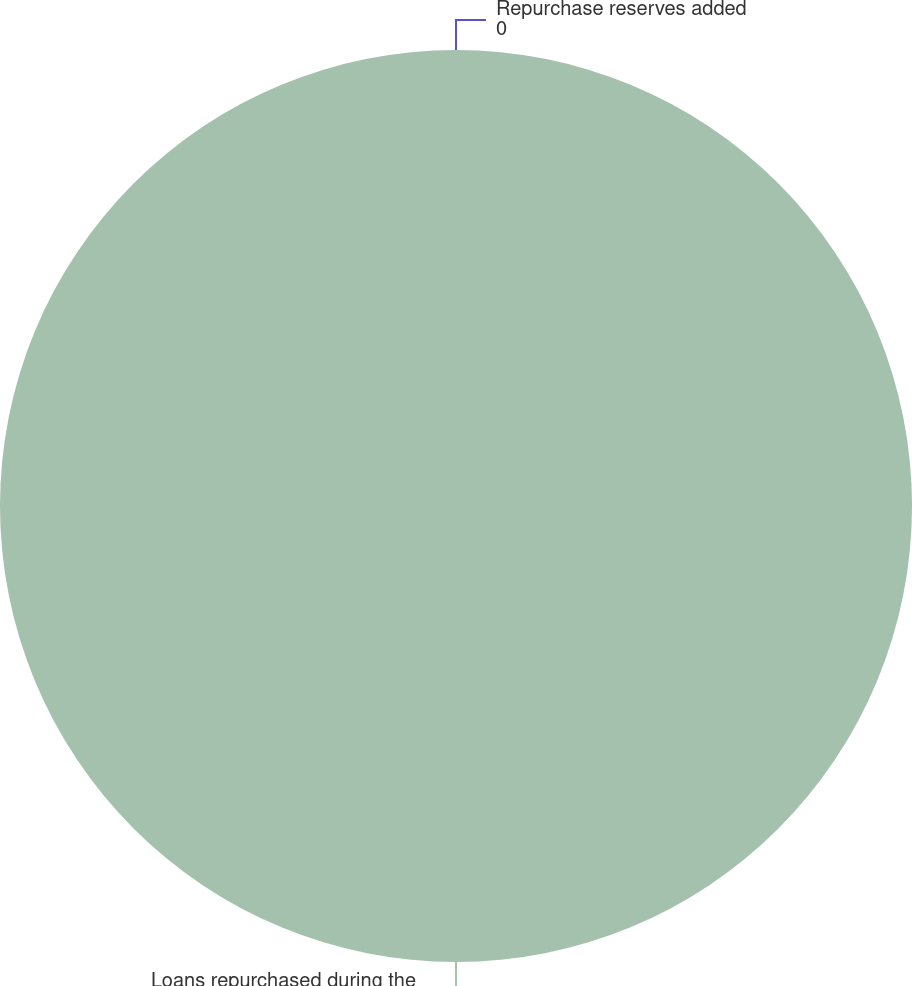<chart> <loc_0><loc_0><loc_500><loc_500><pie_chart><fcel>Loans repurchased during the<fcel>Repurchase reserves added<nl><fcel>100.0%<fcel>0.0%<nl></chart> 